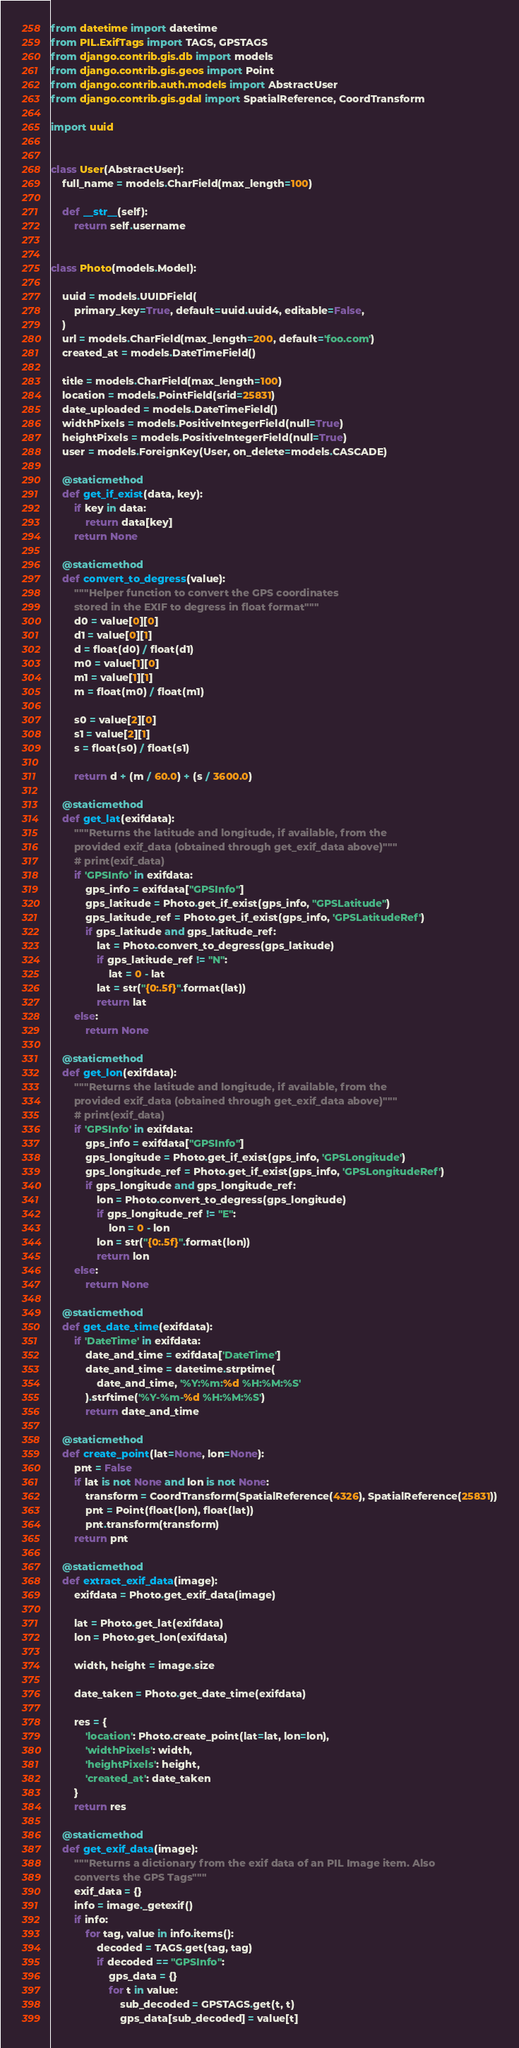Convert code to text. <code><loc_0><loc_0><loc_500><loc_500><_Python_>from datetime import datetime
from PIL.ExifTags import TAGS, GPSTAGS
from django.contrib.gis.db import models
from django.contrib.gis.geos import Point
from django.contrib.auth.models import AbstractUser
from django.contrib.gis.gdal import SpatialReference, CoordTransform

import uuid


class User(AbstractUser):
    full_name = models.CharField(max_length=100)

    def __str__(self):
        return self.username


class Photo(models.Model):

    uuid = models.UUIDField(
        primary_key=True, default=uuid.uuid4, editable=False,
    )
    url = models.CharField(max_length=200, default='foo.com')
    created_at = models.DateTimeField()

    title = models.CharField(max_length=100)
    location = models.PointField(srid=25831)
    date_uploaded = models.DateTimeField()
    widthPixels = models.PositiveIntegerField(null=True)
    heightPixels = models.PositiveIntegerField(null=True)
    user = models.ForeignKey(User, on_delete=models.CASCADE)

    @staticmethod
    def get_if_exist(data, key):
        if key in data:
            return data[key]
        return None

    @staticmethod
    def convert_to_degress(value):
        """Helper function to convert the GPS coordinates
        stored in the EXIF to degress in float format"""
        d0 = value[0][0]
        d1 = value[0][1]
        d = float(d0) / float(d1)
        m0 = value[1][0]
        m1 = value[1][1]
        m = float(m0) / float(m1)

        s0 = value[2][0]
        s1 = value[2][1]
        s = float(s0) / float(s1)

        return d + (m / 60.0) + (s / 3600.0)

    @staticmethod
    def get_lat(exifdata):
        """Returns the latitude and longitude, if available, from the
        provided exif_data (obtained through get_exif_data above)"""
        # print(exif_data)
        if 'GPSInfo' in exifdata:
            gps_info = exifdata["GPSInfo"]
            gps_latitude = Photo.get_if_exist(gps_info, "GPSLatitude")
            gps_latitude_ref = Photo.get_if_exist(gps_info, 'GPSLatitudeRef')
            if gps_latitude and gps_latitude_ref:
                lat = Photo.convert_to_degress(gps_latitude)
                if gps_latitude_ref != "N":
                    lat = 0 - lat
                lat = str("{0:.5f}".format(lat))
                return lat
        else:
            return None

    @staticmethod
    def get_lon(exifdata):
        """Returns the latitude and longitude, if available, from the
        provided exif_data (obtained through get_exif_data above)"""
        # print(exif_data)
        if 'GPSInfo' in exifdata:
            gps_info = exifdata["GPSInfo"]
            gps_longitude = Photo.get_if_exist(gps_info, 'GPSLongitude')
            gps_longitude_ref = Photo.get_if_exist(gps_info, 'GPSLongitudeRef')
            if gps_longitude and gps_longitude_ref:
                lon = Photo.convert_to_degress(gps_longitude)
                if gps_longitude_ref != "E":
                    lon = 0 - lon
                lon = str("{0:.5f}".format(lon))
                return lon
        else:
            return None

    @staticmethod
    def get_date_time(exifdata):
        if 'DateTime' in exifdata:
            date_and_time = exifdata['DateTime']
            date_and_time = datetime.strptime(
                date_and_time, '%Y:%m:%d %H:%M:%S'
            ).strftime('%Y-%m-%d %H:%M:%S')
            return date_and_time

    @staticmethod
    def create_point(lat=None, lon=None):
        pnt = False
        if lat is not None and lon is not None:
            transform = CoordTransform(SpatialReference(4326), SpatialReference(25831))
            pnt = Point(float(lon), float(lat))
            pnt.transform(transform)
        return pnt

    @staticmethod
    def extract_exif_data(image):
        exifdata = Photo.get_exif_data(image)

        lat = Photo.get_lat(exifdata)
        lon = Photo.get_lon(exifdata)

        width, height = image.size

        date_taken = Photo.get_date_time(exifdata)

        res = {
            'location': Photo.create_point(lat=lat, lon=lon),
            'widthPixels': width,
            'heightPixels': height,
            'created_at': date_taken
        }
        return res

    @staticmethod
    def get_exif_data(image):
        """Returns a dictionary from the exif data of an PIL Image item. Also
        converts the GPS Tags"""
        exif_data = {}
        info = image._getexif()
        if info:
            for tag, value in info.items():
                decoded = TAGS.get(tag, tag)
                if decoded == "GPSInfo":
                    gps_data = {}
                    for t in value:
                        sub_decoded = GPSTAGS.get(t, t)
                        gps_data[sub_decoded] = value[t]
</code> 